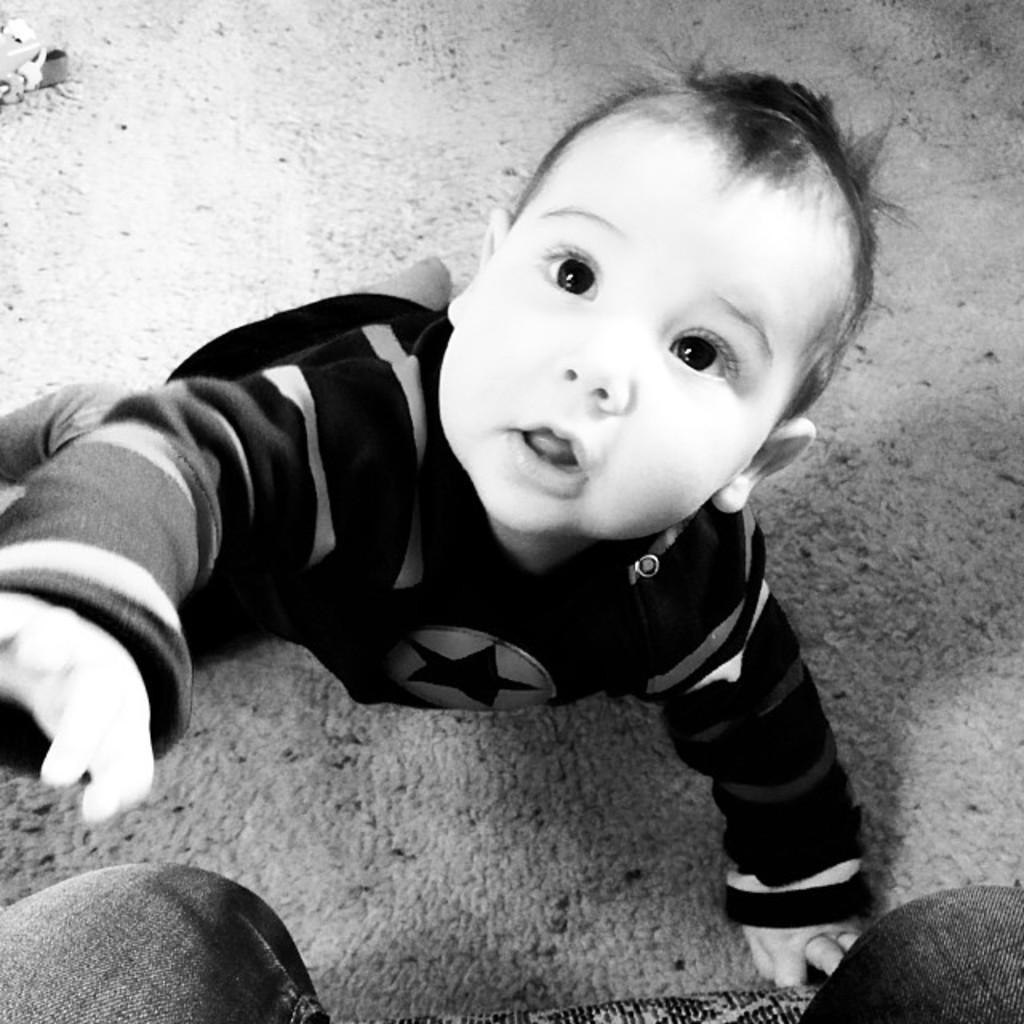Can you describe this image briefly? This is a black and white image in this image there is a baby on a ground and there is a person sitting on a chair. 